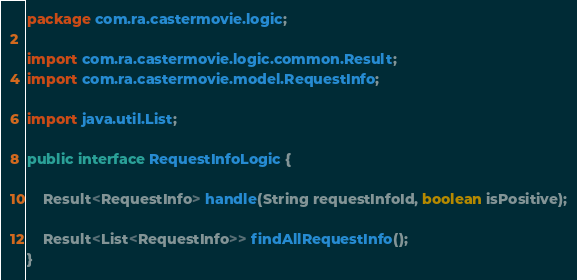<code> <loc_0><loc_0><loc_500><loc_500><_Java_>package com.ra.castermovie.logic;

import com.ra.castermovie.logic.common.Result;
import com.ra.castermovie.model.RequestInfo;

import java.util.List;

public interface RequestInfoLogic {

    Result<RequestInfo> handle(String requestInfoId, boolean isPositive);

    Result<List<RequestInfo>> findAllRequestInfo();
}
</code> 